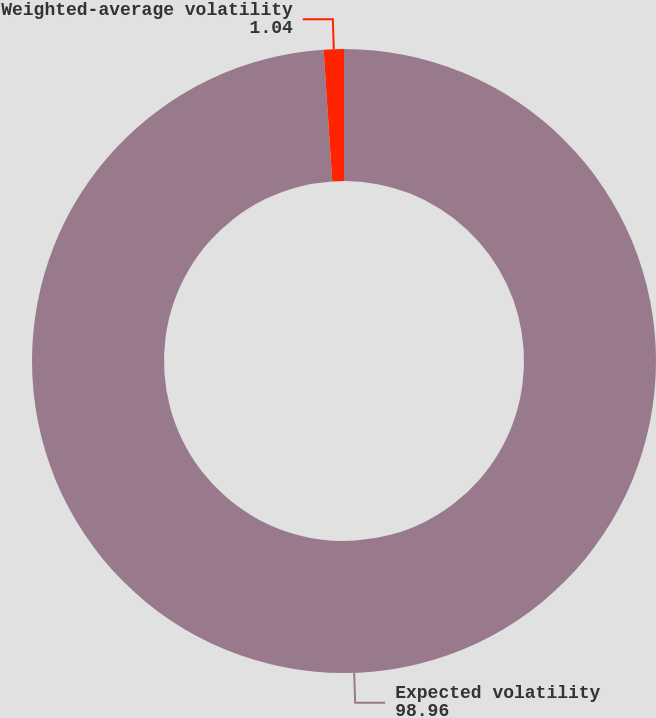Convert chart. <chart><loc_0><loc_0><loc_500><loc_500><pie_chart><fcel>Expected volatility<fcel>Weighted-average volatility<nl><fcel>98.96%<fcel>1.04%<nl></chart> 